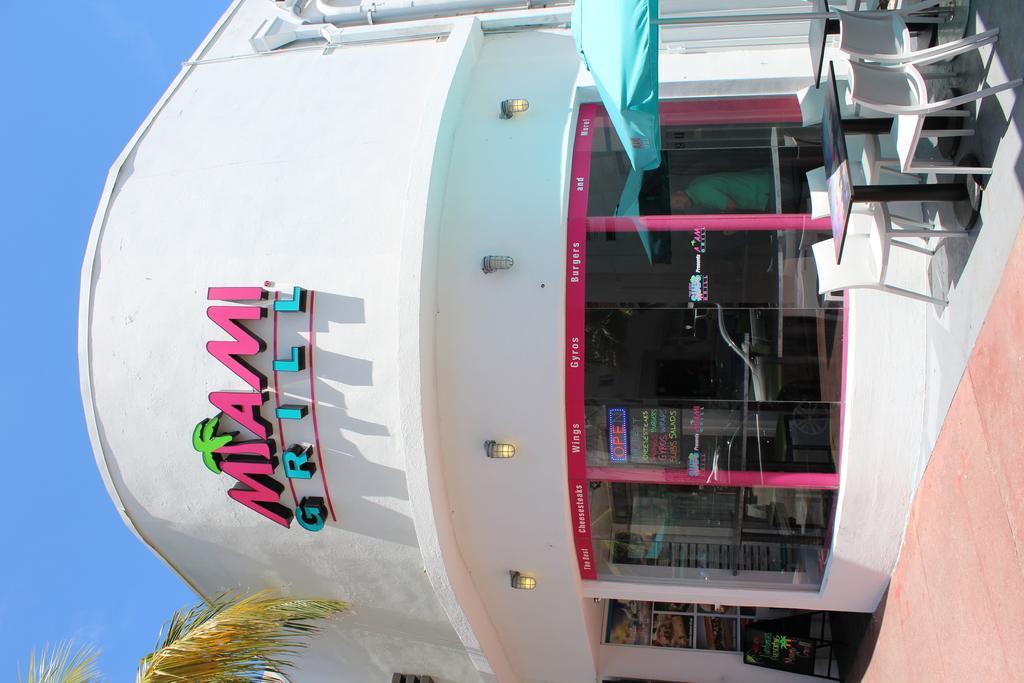How would you summarize this image in a sentence or two? In this image, we can see a store with glass walls. Through the glass wall, we can see the inside view. There are so many things we can see. In the middle of the image, we can see few lights. Top of the image, there are few pipes. Tables and chairs we can see here. At the bottom, we can see a tree leaves and footpath. Left side of the image, there is a clear sky. 